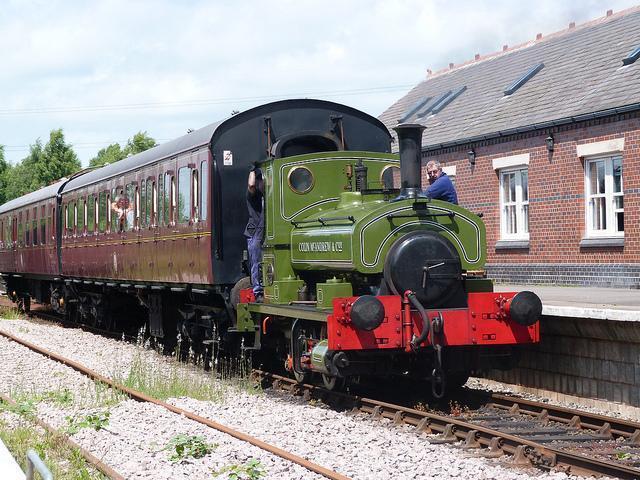How many men are hanging onto it?
Give a very brief answer. 2. How many sheep are there?
Give a very brief answer. 0. 